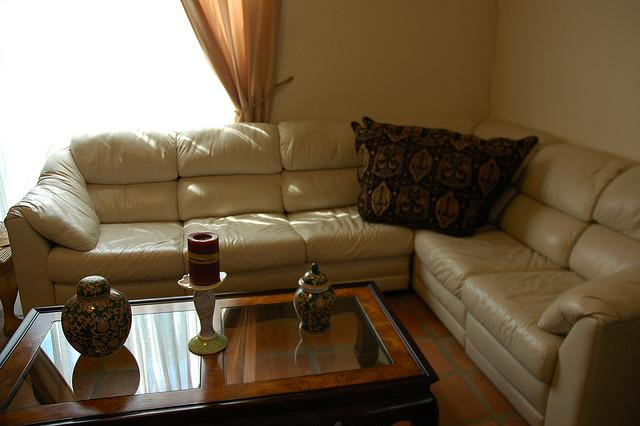Which item is most likely made from animal skin? couch 